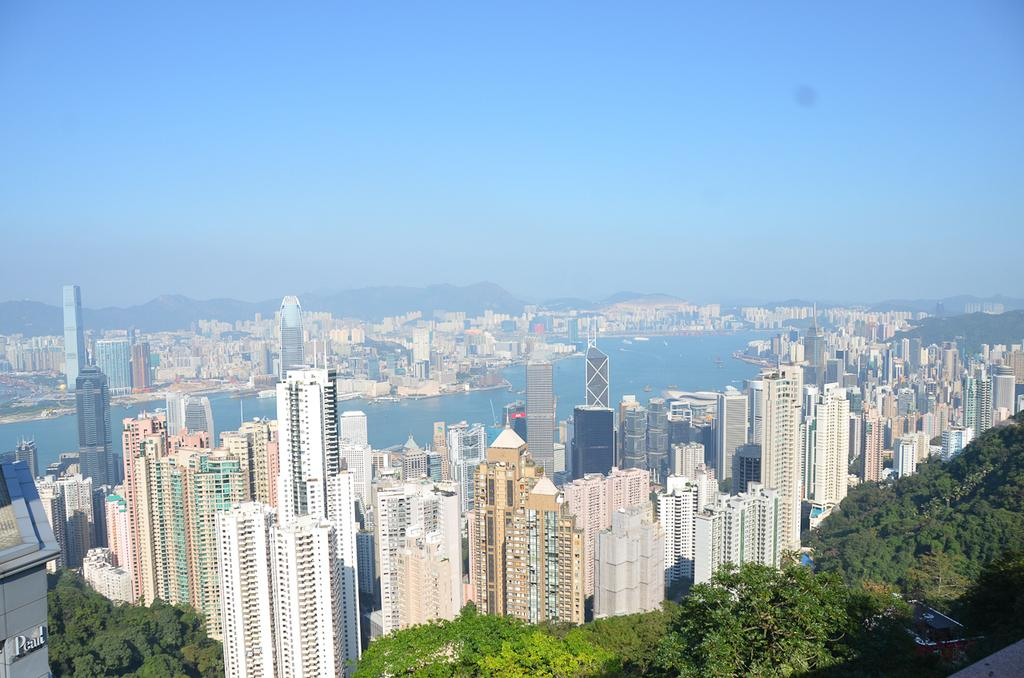What types of structures are present in the image? There are buildings in the image, from left to right. What natural element can be seen in the image? There is water visible in the image. What type of vegetation is present in the image? There are trees in the image, from left to right. What is the color of the sky in the image? The sky is blue in color. What type of cream is being used to attack the buildings in the image? There is no cream or attack present in the image; it features buildings, water, trees, and a blue sky. 